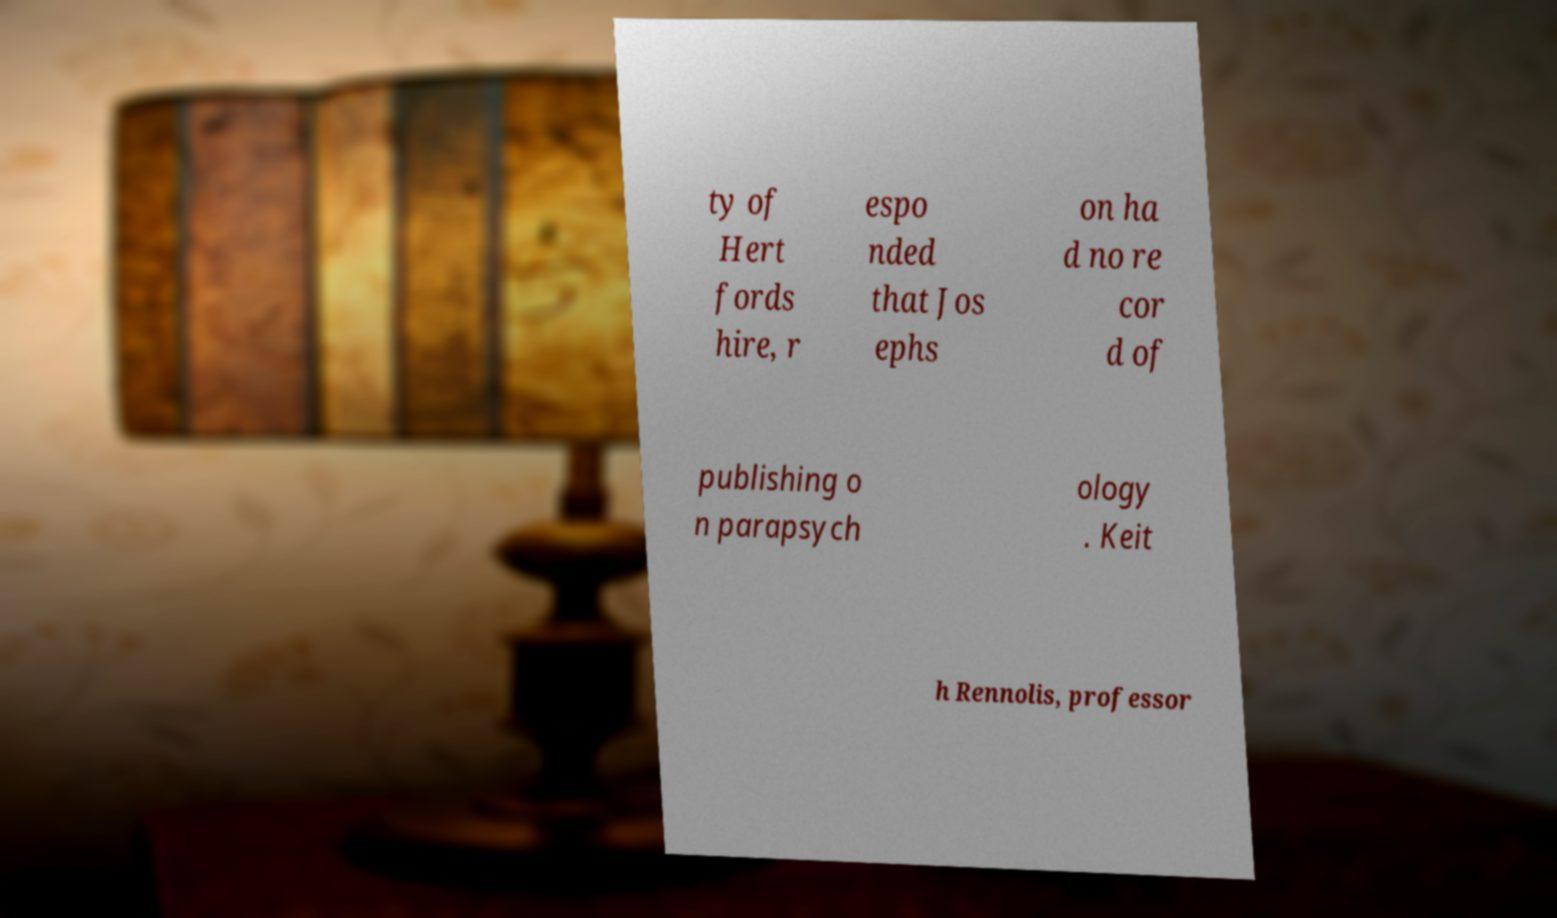Can you accurately transcribe the text from the provided image for me? ty of Hert fords hire, r espo nded that Jos ephs on ha d no re cor d of publishing o n parapsych ology . Keit h Rennolis, professor 